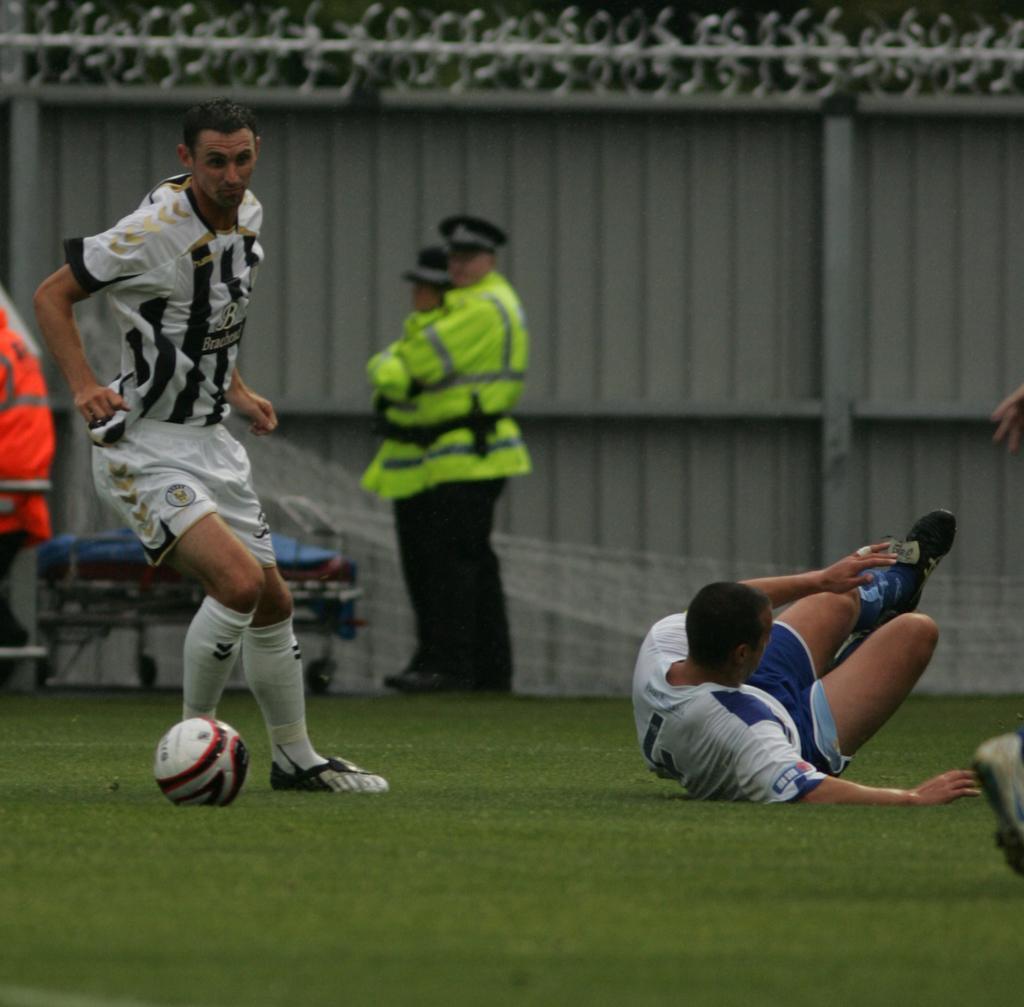Could you give a brief overview of what you see in this image? In this picture we can see some persons in the ground. This is grass. And we can see a person playing with the ball. 